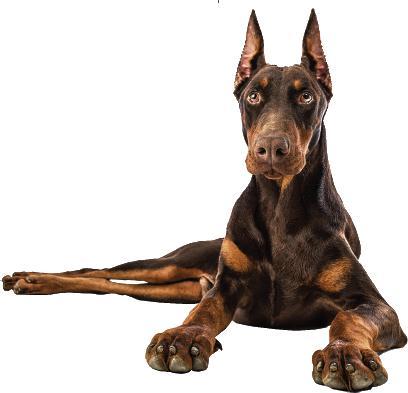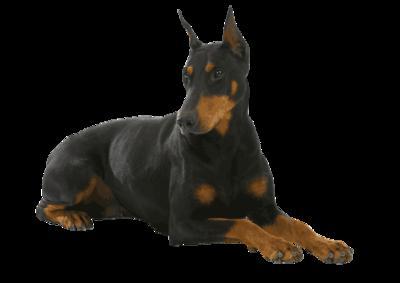The first image is the image on the left, the second image is the image on the right. Evaluate the accuracy of this statement regarding the images: "The dog in the image on the left is lying down.". Is it true? Answer yes or no. Yes. The first image is the image on the left, the second image is the image on the right. Assess this claim about the two images: "One image shows a forward-facing brown-and-tan doberman, with its front paws extended forward.". Correct or not? Answer yes or no. Yes. 